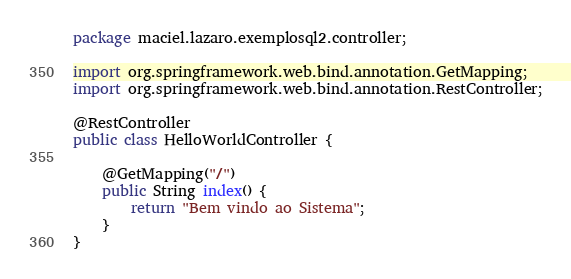<code> <loc_0><loc_0><loc_500><loc_500><_Java_>package maciel.lazaro.exemplosql2.controller;

import org.springframework.web.bind.annotation.GetMapping;
import org.springframework.web.bind.annotation.RestController;

@RestController
public class HelloWorldController {

    @GetMapping("/")
    public String index() {
        return "Bem vindo ao Sistema";
    }
}
</code> 